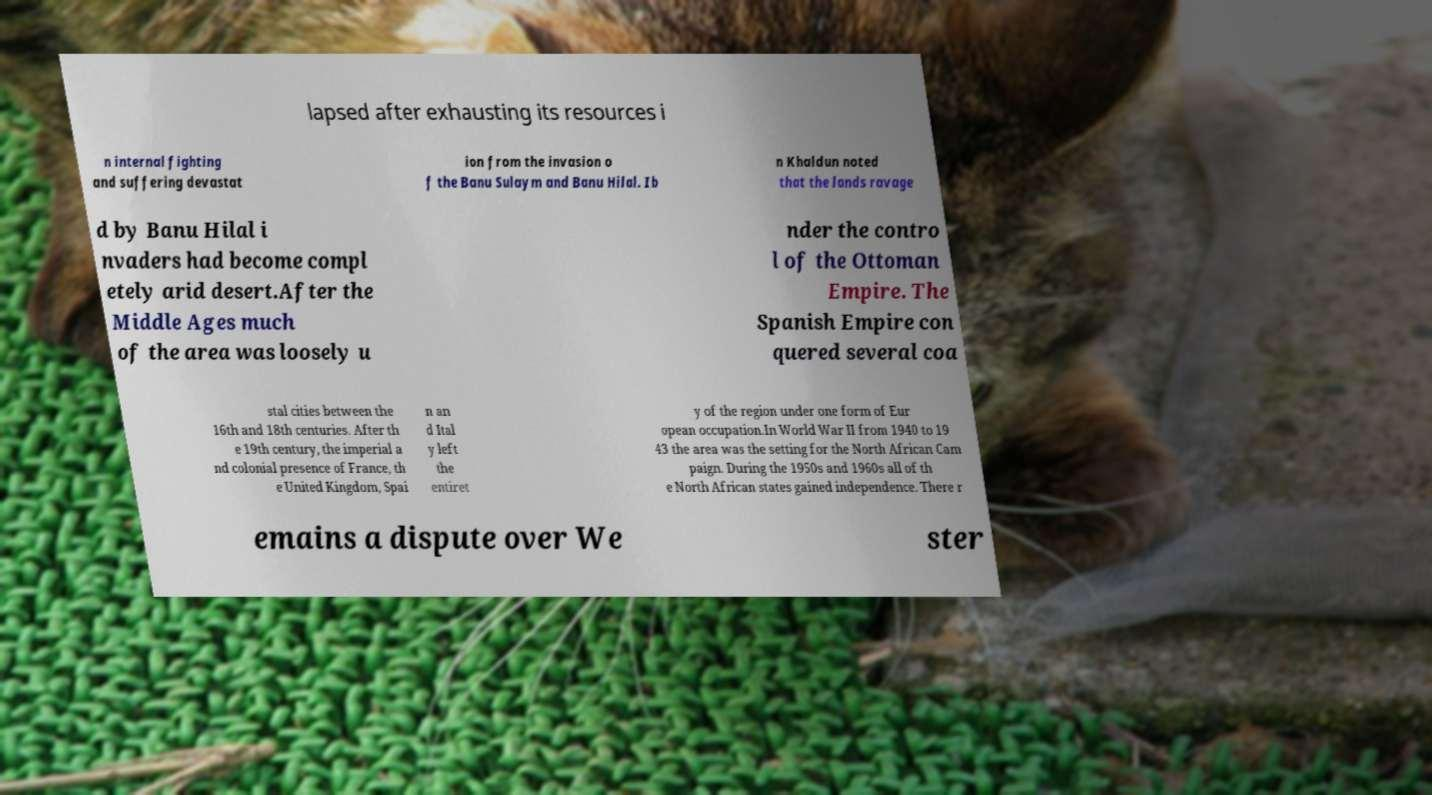Can you accurately transcribe the text from the provided image for me? lapsed after exhausting its resources i n internal fighting and suffering devastat ion from the invasion o f the Banu Sulaym and Banu Hilal. Ib n Khaldun noted that the lands ravage d by Banu Hilal i nvaders had become compl etely arid desert.After the Middle Ages much of the area was loosely u nder the contro l of the Ottoman Empire. The Spanish Empire con quered several coa stal cities between the 16th and 18th centuries. After th e 19th century, the imperial a nd colonial presence of France, th e United Kingdom, Spai n an d Ital y left the entiret y of the region under one form of Eur opean occupation.In World War II from 1940 to 19 43 the area was the setting for the North African Cam paign. During the 1950s and 1960s all of th e North African states gained independence. There r emains a dispute over We ster 